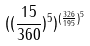Convert formula to latex. <formula><loc_0><loc_0><loc_500><loc_500>( ( \frac { 1 5 } { 3 6 0 } ) ^ { 5 } ) ^ { ( \frac { 3 2 6 } { 1 9 5 } ) ^ { 5 } }</formula> 